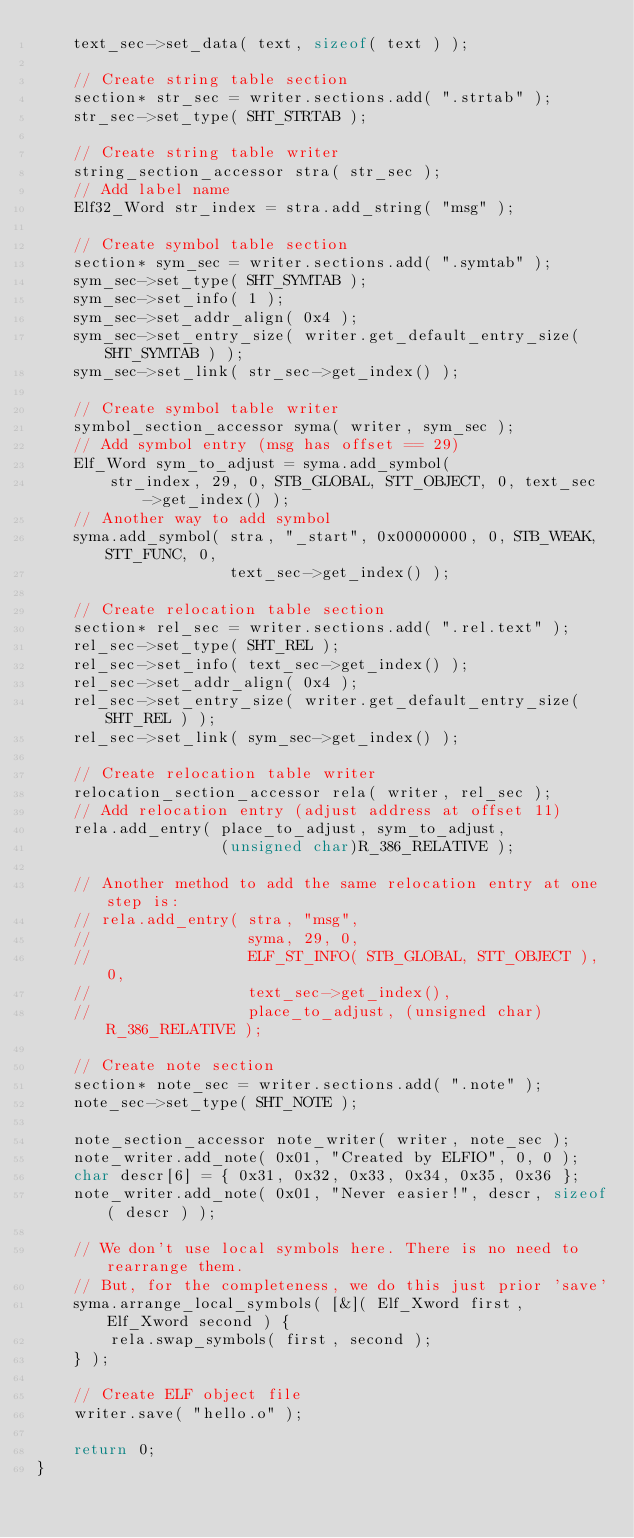Convert code to text. <code><loc_0><loc_0><loc_500><loc_500><_C++_>    text_sec->set_data( text, sizeof( text ) );

    // Create string table section
    section* str_sec = writer.sections.add( ".strtab" );
    str_sec->set_type( SHT_STRTAB );

    // Create string table writer
    string_section_accessor stra( str_sec );
    // Add label name
    Elf32_Word str_index = stra.add_string( "msg" );

    // Create symbol table section
    section* sym_sec = writer.sections.add( ".symtab" );
    sym_sec->set_type( SHT_SYMTAB );
    sym_sec->set_info( 1 );
    sym_sec->set_addr_align( 0x4 );
    sym_sec->set_entry_size( writer.get_default_entry_size( SHT_SYMTAB ) );
    sym_sec->set_link( str_sec->get_index() );

    // Create symbol table writer
    symbol_section_accessor syma( writer, sym_sec );
    // Add symbol entry (msg has offset == 29)
    Elf_Word sym_to_adjust = syma.add_symbol(
        str_index, 29, 0, STB_GLOBAL, STT_OBJECT, 0, text_sec->get_index() );
    // Another way to add symbol
    syma.add_symbol( stra, "_start", 0x00000000, 0, STB_WEAK, STT_FUNC, 0,
                     text_sec->get_index() );

    // Create relocation table section
    section* rel_sec = writer.sections.add( ".rel.text" );
    rel_sec->set_type( SHT_REL );
    rel_sec->set_info( text_sec->get_index() );
    rel_sec->set_addr_align( 0x4 );
    rel_sec->set_entry_size( writer.get_default_entry_size( SHT_REL ) );
    rel_sec->set_link( sym_sec->get_index() );

    // Create relocation table writer
    relocation_section_accessor rela( writer, rel_sec );
    // Add relocation entry (adjust address at offset 11)
    rela.add_entry( place_to_adjust, sym_to_adjust,
                    (unsigned char)R_386_RELATIVE );

    // Another method to add the same relocation entry at one step is:
    // rela.add_entry( stra, "msg",
    //                 syma, 29, 0,
    //                 ELF_ST_INFO( STB_GLOBAL, STT_OBJECT ), 0,
    //                 text_sec->get_index(),
    //                 place_to_adjust, (unsigned char)R_386_RELATIVE );

    // Create note section
    section* note_sec = writer.sections.add( ".note" );
    note_sec->set_type( SHT_NOTE );

    note_section_accessor note_writer( writer, note_sec );
    note_writer.add_note( 0x01, "Created by ELFIO", 0, 0 );
    char descr[6] = { 0x31, 0x32, 0x33, 0x34, 0x35, 0x36 };
    note_writer.add_note( 0x01, "Never easier!", descr, sizeof( descr ) );

    // We don't use local symbols here. There is no need to rearrange them.
    // But, for the completeness, we do this just prior 'save'
    syma.arrange_local_symbols( [&]( Elf_Xword first, Elf_Xword second ) {
        rela.swap_symbols( first, second );
    } );

    // Create ELF object file
    writer.save( "hello.o" );

    return 0;
}
</code> 